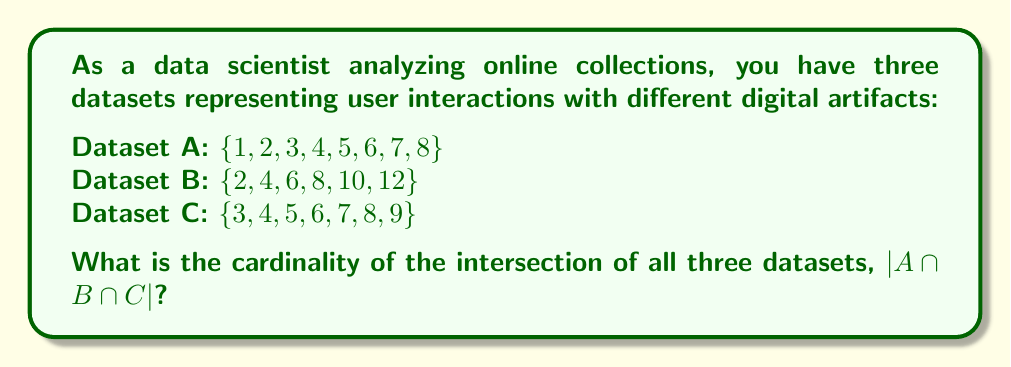Give your solution to this math problem. To solve this problem, we need to follow these steps:

1) First, let's identify the elements that are common to all three sets. We can do this by listing out the elements of each set and finding those that appear in all three:

   A: $\{1, 2, 3, 4, 5, 6, 7, 8\}$
   B: $\{2, 4, 6, 8, 10, 12\}$
   C: $\{3, 4, 5, 6, 7, 8, 9\}$

2) Looking at these sets, we can see that the elements 4, 6, and 8 appear in all three sets.

3) Therefore, the intersection of all three sets is:

   $A \cap B \cap C = \{4, 6, 8\}$

4) The cardinality of a set is the number of elements in the set. In this case, the intersection set has 3 elements.

5) Thus, the cardinality of the intersection is:

   $|A \cap B \cap C| = |\{4, 6, 8\}| = 3$

This result indicates that there are 3 common elements across all three datasets, which could represent user interactions that are consistent across different types of digital artifacts in the online collection.
Answer: $|A \cap B \cap C| = 3$ 